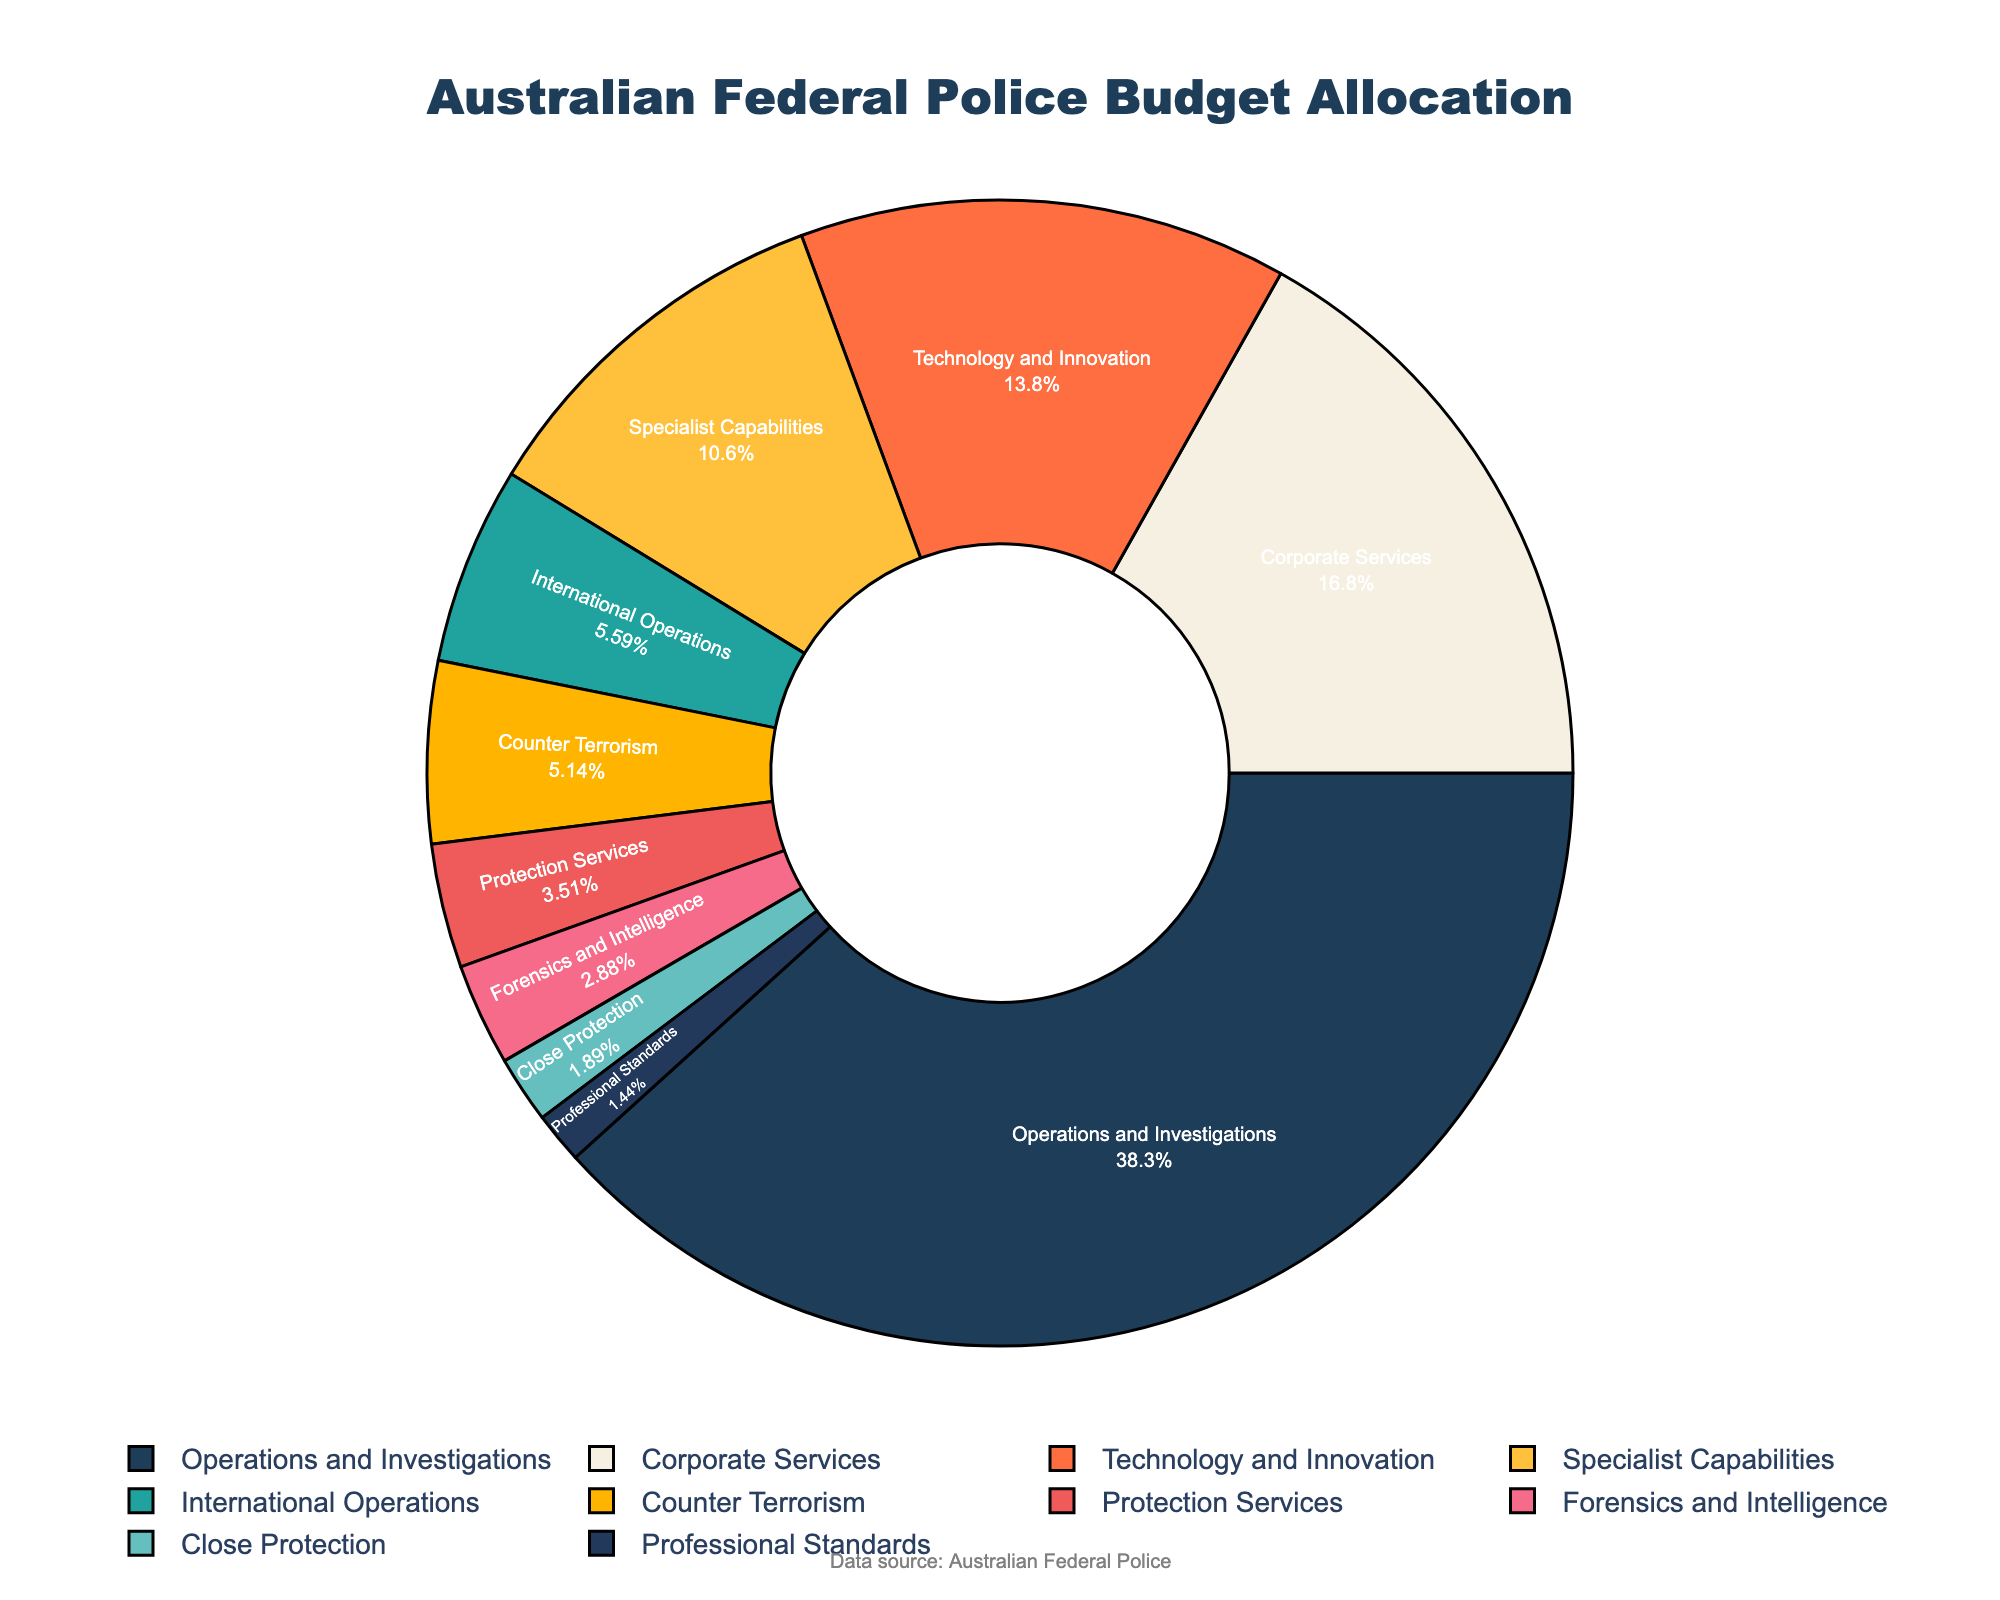What percentage of the budget is allocated to Operations and Investigations? Referring to the figure, the slice labeled "Operations and Investigations" shows the percentage directly.
Answer: 42.5% Which category receives the least amount of budget allocation? Referring to the figure, the smallest slice corresponds to "Professional Standards".
Answer: Professional Standards How many categories have a budget allocation of less than 5%? Referring to the figure, "Counter Terrorism" (5.7%) is the threshold category, and the categories below it are "Protection Services" (3.9%), "Professional Standards" (1.6%), "Close Protection" (2.1%), and "Forensics and Intelligence" (3.2%). These are four categories.
Answer: 4 Which category receives more budget allocation: Technology and Innovation or Specialist Capabilities? Referring to the figure, "Technology and Innovation" has 15.3% and "Specialist Capabilities" has 11.8%.
Answer: Technology and Innovation What is the combined budget allocation for Counter Terrorism and Close Protection? Referring to the figure, add the percentages of "Counter Terrorism" (5.7%) and "Close Protection" (2.1%). The combined budget allocation is 5.7 + 2.1 = 7.8%.
Answer: 7.8% Which category has a medium-sized slice colored in a shade of blue? Referring to the figure, the medium-sized blue-colored slice represents "Specialist Capabilities."
Answer: Specialist Capabilities What is the difference in budget allocation between Operations and Investigations and Technology and Innovation? Referring to the figure, subtract the percentage of "Technology and Innovation" (15.3%) from "Operations and Investigations" (42.5%). The difference is 42.5 - 15.3 = 27.2%.
Answer: 27.2% How does the budget allocation for International Operations compare to Counter Terrorism? Referring to the figure, "International Operations" has 6.2% compared to "Counter Terrorism" which has 5.7%. International Operations has a slightly higher budget allocation.
Answer: International Operations What is the total budget allocation for categories with over 10% allocation? Referring to the figure, the categories above 10% are "Operations and Investigations" (42.5%), "Corporate Services" (18.7%), and "Technology and Innovation" (15.3%). The total is 42.5 + 18.7 + 15.3 = 76.5%.
Answer: 76.5% What percentage of the budget is allocated to categories involved in technological and specialist areas (Technology and Innovation, Specialist Capabilities, Forensics and Intelligence)? Referring to the figure, add the percentages for "Technology and Innovation" (15.3%), "Specialist Capabilities" (11.8%), and "Forensics and Intelligence" (3.2%). The combined total is 15.3 + 11.8 + 3.2 = 30.3%.
Answer: 30.3% 